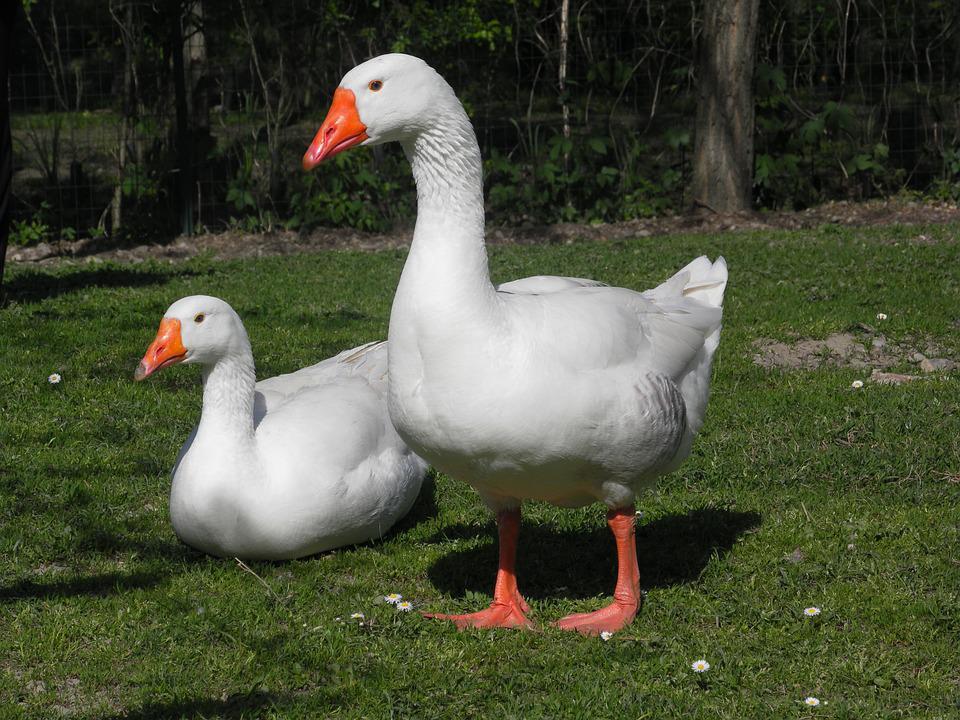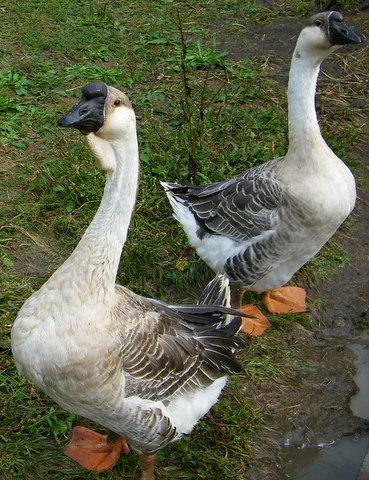The first image is the image on the left, the second image is the image on the right. Evaluate the accuracy of this statement regarding the images: "There are at least two animals in every image.". Is it true? Answer yes or no. Yes. 